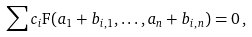<formula> <loc_0><loc_0><loc_500><loc_500>\sum c _ { i } \mathrm F ( a _ { 1 } + b _ { i , 1 } , \dots , a _ { n } + b _ { i , n } ) = 0 \, ,</formula> 